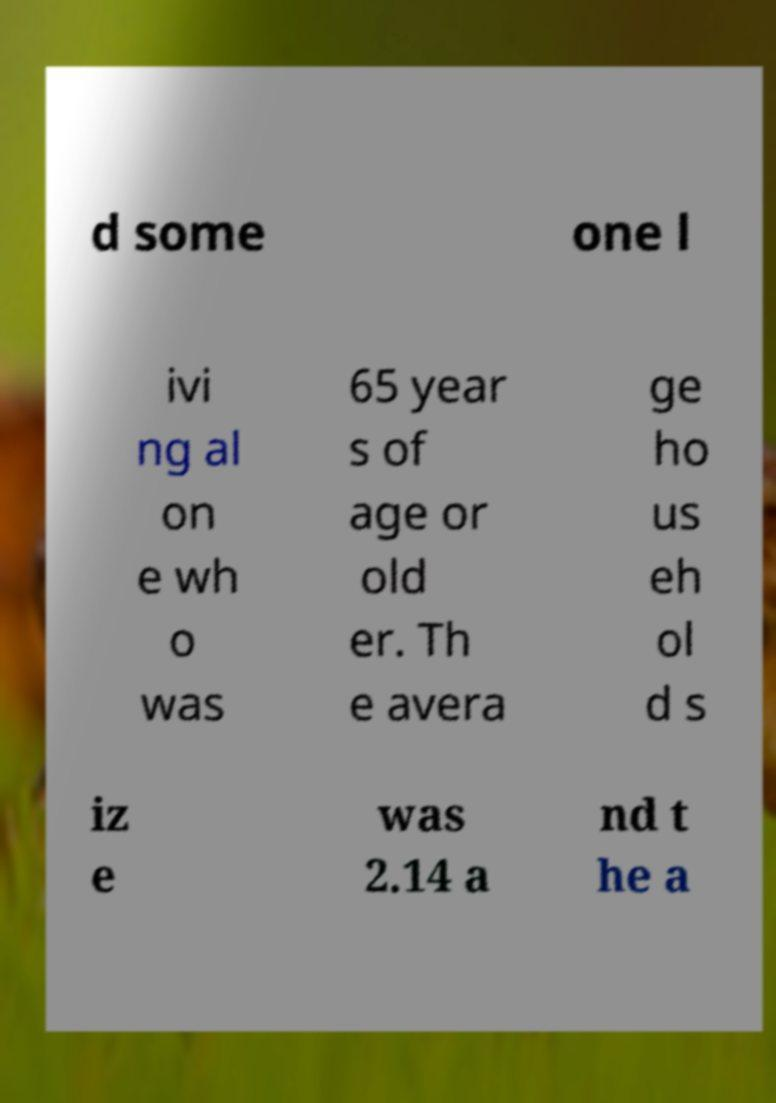I need the written content from this picture converted into text. Can you do that? d some one l ivi ng al on e wh o was 65 year s of age or old er. Th e avera ge ho us eh ol d s iz e was 2.14 a nd t he a 